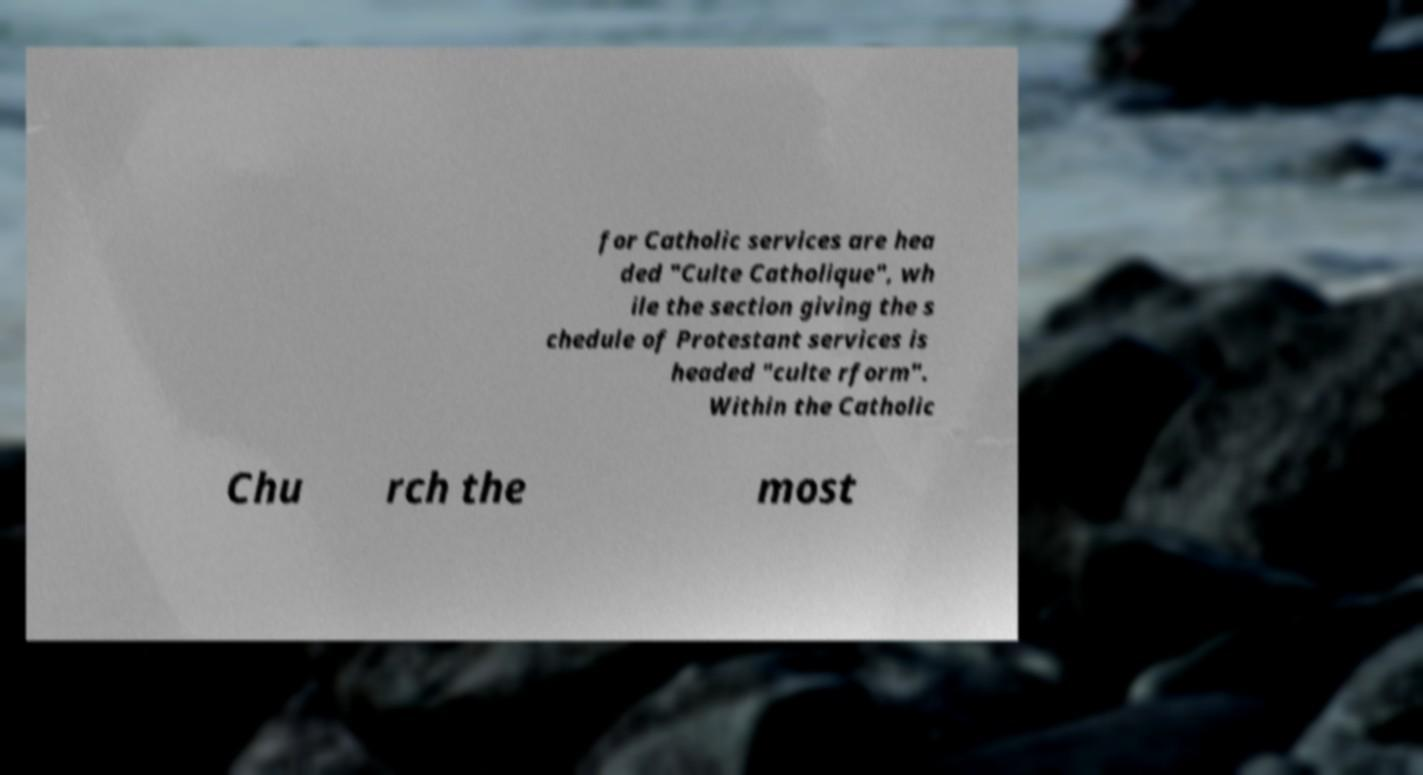Can you accurately transcribe the text from the provided image for me? for Catholic services are hea ded "Culte Catholique", wh ile the section giving the s chedule of Protestant services is headed "culte rform". Within the Catholic Chu rch the most 